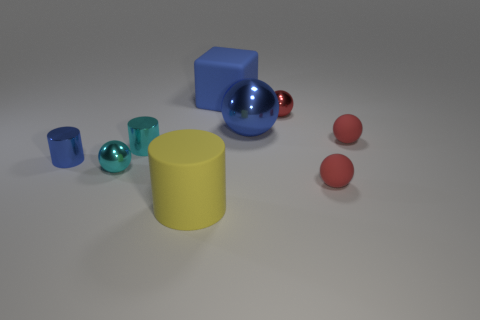Subtract all purple cubes. How many red spheres are left? 3 Subtract all cyan metallic balls. How many balls are left? 4 Subtract all cyan spheres. How many spheres are left? 4 Subtract all brown balls. Subtract all blue blocks. How many balls are left? 5 Add 1 big blue metallic objects. How many objects exist? 10 Subtract all balls. How many objects are left? 4 Add 7 small cyan metallic cylinders. How many small cyan metallic cylinders are left? 8 Add 8 small cyan cylinders. How many small cyan cylinders exist? 9 Subtract 0 green spheres. How many objects are left? 9 Subtract all large blue things. Subtract all tiny blue metallic cylinders. How many objects are left? 6 